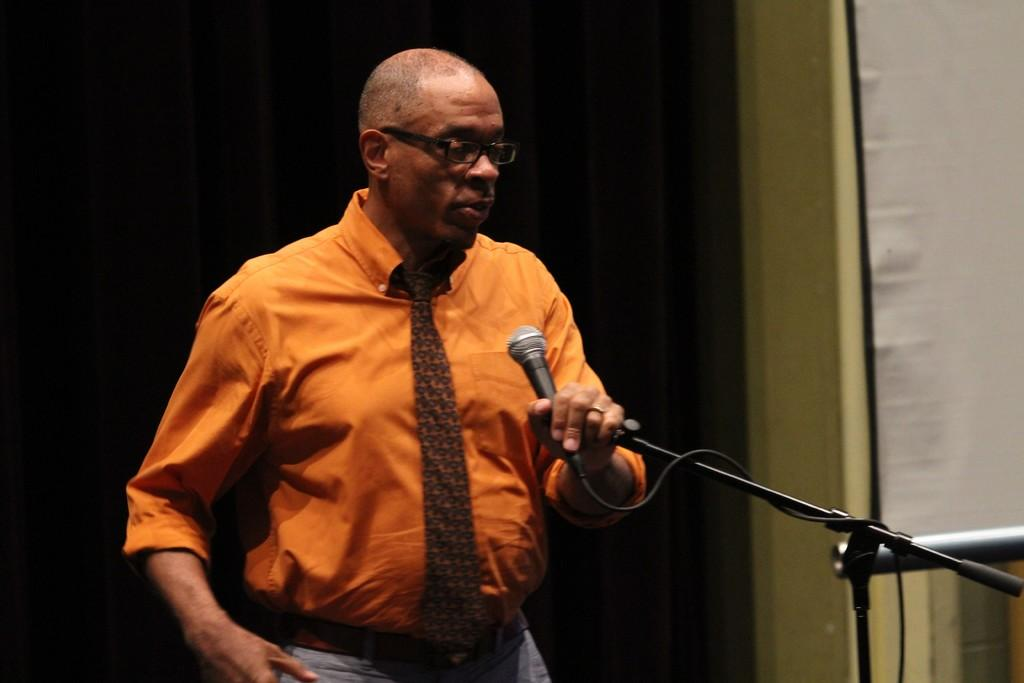What is the person in the image wearing? The person is wearing an orange shirt and tie. What accessory is the person wearing on their face? The person is wearing spectacles. What is the person holding in the image? The person is holding a mic. What is present in front of the person to support the mic? There is a mic stand in front of the person. What can be seen in the background of the image? There is a black curtain in the background of the image. What type of pencil is visible on the person's desk in the image? There is no pencil visible in the image; the person is holding a mic and there is a mic stand in front of them. 